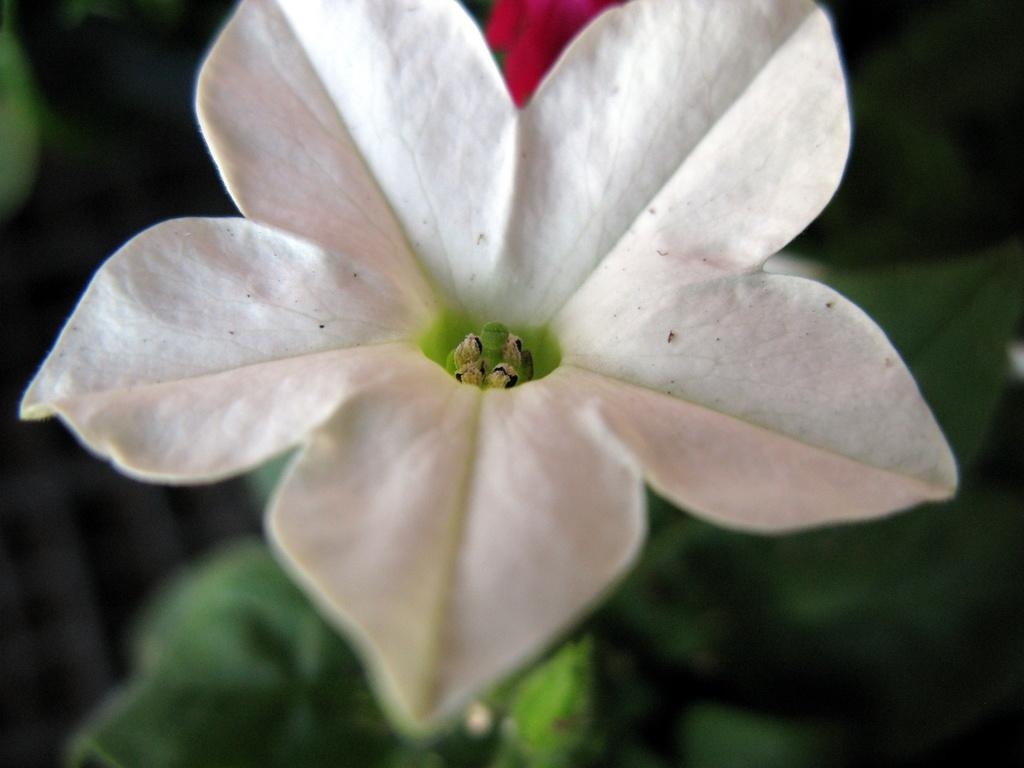What is the main subject of the picture? The main subject of the picture is a flower. What color is the flower? The flower is white in color. What other color is present in the picture? There is a green color object in the picture. What type of vegetation can be seen below the flower? There is greenery visible below the flower. How many tomatoes are growing on the flower in the image? There are no tomatoes present in the image, as it features a white flower with greenery below it. 